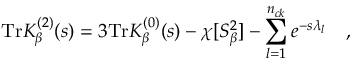<formula> <loc_0><loc_0><loc_500><loc_500>T r K _ { \beta } ^ { ( 2 ) } ( s ) = 3 T r K _ { \beta } ^ { ( 0 ) } ( s ) - \chi [ S _ { \beta } ^ { 2 } ] - \sum _ { l = 1 } ^ { n _ { c k } } e ^ { - s \lambda _ { l } } ,</formula> 